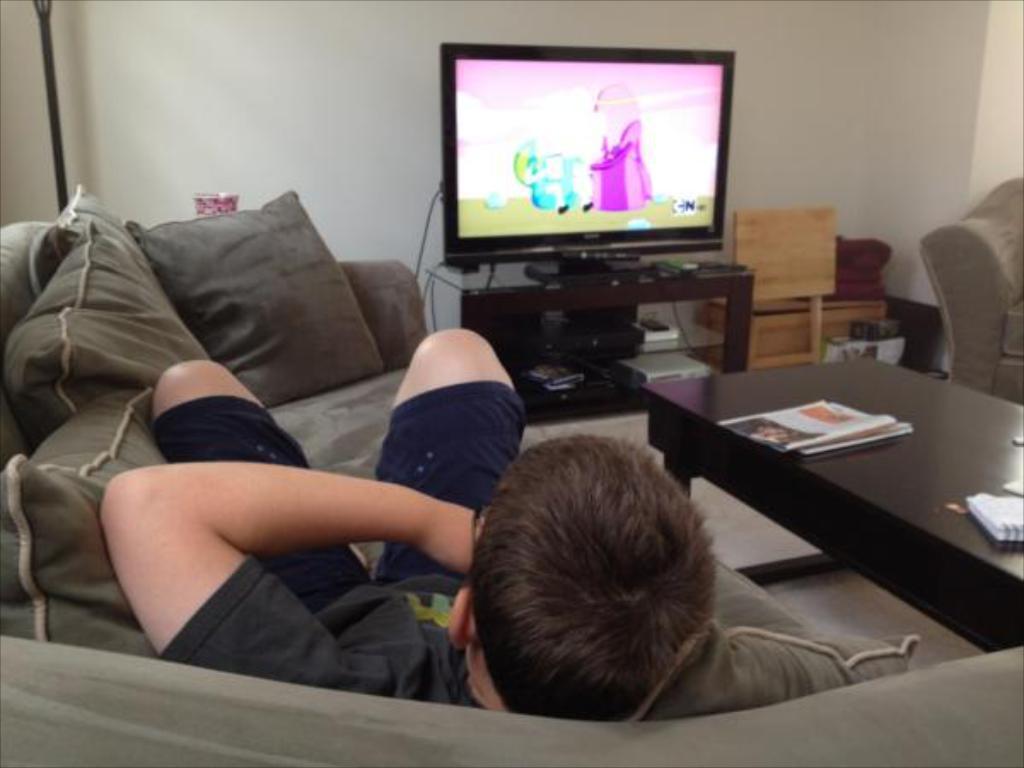Could you give a brief overview of what you see in this image? In this image we can see a person lying on a sofa. On the sofa there are pillars. Near to the sofa there is a table. On the table there are papers. In the back there is a television on a stand. In the stand there are few items. Near to that there are wooden objects. In the back there is a wall. On the right side there is another sofa. 